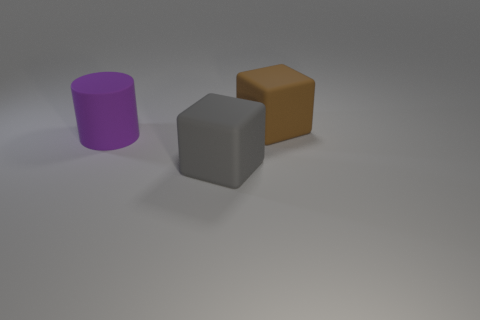How many other things are the same shape as the big gray matte object?
Ensure brevity in your answer.  1. There is a big purple object that is in front of the large brown rubber cube; does it have the same shape as the object that is on the right side of the gray thing?
Ensure brevity in your answer.  No. There is a matte object to the left of the object in front of the purple rubber thing; what number of cubes are in front of it?
Ensure brevity in your answer.  1. The cylinder has what color?
Offer a terse response. Purple. What is the material of the big gray thing that is the same shape as the big brown rubber thing?
Offer a very short reply. Rubber. There is a large object to the left of the large block that is left of the big block behind the gray rubber thing; what is it made of?
Keep it short and to the point. Rubber. What is the size of the cylinder that is made of the same material as the brown block?
Offer a terse response. Large. Are there any other things that are the same color as the rubber cylinder?
Your response must be concise. No. Is the color of the big cube that is to the right of the gray block the same as the thing on the left side of the gray thing?
Your answer should be compact. No. There is a block that is in front of the brown matte cube; what color is it?
Ensure brevity in your answer.  Gray. 